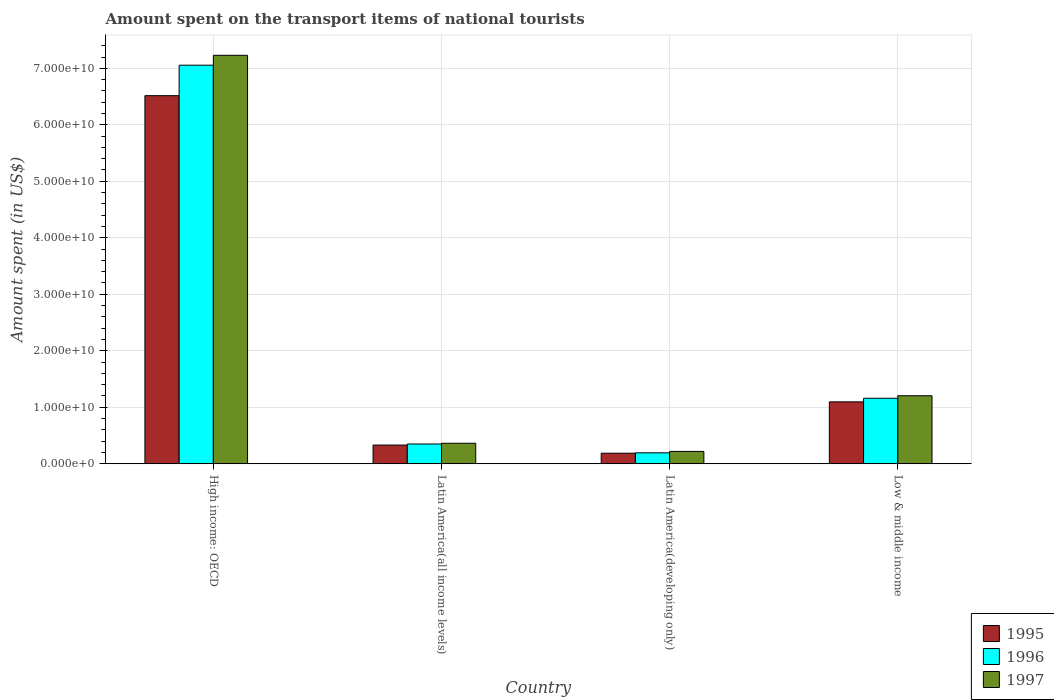How many different coloured bars are there?
Provide a succinct answer. 3. How many groups of bars are there?
Your response must be concise. 4. Are the number of bars per tick equal to the number of legend labels?
Your answer should be compact. Yes. Are the number of bars on each tick of the X-axis equal?
Provide a short and direct response. Yes. How many bars are there on the 3rd tick from the left?
Give a very brief answer. 3. How many bars are there on the 2nd tick from the right?
Make the answer very short. 3. What is the label of the 3rd group of bars from the left?
Offer a terse response. Latin America(developing only). In how many cases, is the number of bars for a given country not equal to the number of legend labels?
Offer a terse response. 0. What is the amount spent on the transport items of national tourists in 1997 in High income: OECD?
Your response must be concise. 7.23e+1. Across all countries, what is the maximum amount spent on the transport items of national tourists in 1995?
Your answer should be compact. 6.52e+1. Across all countries, what is the minimum amount spent on the transport items of national tourists in 1996?
Your answer should be compact. 1.93e+09. In which country was the amount spent on the transport items of national tourists in 1997 maximum?
Keep it short and to the point. High income: OECD. In which country was the amount spent on the transport items of national tourists in 1995 minimum?
Provide a short and direct response. Latin America(developing only). What is the total amount spent on the transport items of national tourists in 1995 in the graph?
Your answer should be very brief. 8.13e+1. What is the difference between the amount spent on the transport items of national tourists in 1995 in Latin America(all income levels) and that in Latin America(developing only)?
Your response must be concise. 1.44e+09. What is the difference between the amount spent on the transport items of national tourists in 1997 in Latin America(all income levels) and the amount spent on the transport items of national tourists in 1996 in High income: OECD?
Ensure brevity in your answer.  -6.69e+1. What is the average amount spent on the transport items of national tourists in 1996 per country?
Make the answer very short. 2.19e+1. What is the difference between the amount spent on the transport items of national tourists of/in 1996 and amount spent on the transport items of national tourists of/in 1997 in Latin America(developing only)?
Keep it short and to the point. -2.50e+08. What is the ratio of the amount spent on the transport items of national tourists in 1996 in High income: OECD to that in Latin America(developing only)?
Provide a succinct answer. 36.51. Is the amount spent on the transport items of national tourists in 1996 in High income: OECD less than that in Latin America(developing only)?
Keep it short and to the point. No. What is the difference between the highest and the second highest amount spent on the transport items of national tourists in 1997?
Give a very brief answer. 6.87e+1. What is the difference between the highest and the lowest amount spent on the transport items of national tourists in 1995?
Offer a very short reply. 6.33e+1. What does the 3rd bar from the left in High income: OECD represents?
Offer a very short reply. 1997. Is it the case that in every country, the sum of the amount spent on the transport items of national tourists in 1997 and amount spent on the transport items of national tourists in 1996 is greater than the amount spent on the transport items of national tourists in 1995?
Keep it short and to the point. Yes. Are all the bars in the graph horizontal?
Offer a very short reply. No. Are the values on the major ticks of Y-axis written in scientific E-notation?
Ensure brevity in your answer.  Yes. How are the legend labels stacked?
Keep it short and to the point. Vertical. What is the title of the graph?
Your answer should be compact. Amount spent on the transport items of national tourists. What is the label or title of the X-axis?
Your answer should be very brief. Country. What is the label or title of the Y-axis?
Offer a very short reply. Amount spent (in US$). What is the Amount spent (in US$) of 1995 in High income: OECD?
Give a very brief answer. 6.52e+1. What is the Amount spent (in US$) of 1996 in High income: OECD?
Provide a succinct answer. 7.06e+1. What is the Amount spent (in US$) in 1997 in High income: OECD?
Your response must be concise. 7.23e+1. What is the Amount spent (in US$) of 1995 in Latin America(all income levels)?
Ensure brevity in your answer.  3.31e+09. What is the Amount spent (in US$) in 1996 in Latin America(all income levels)?
Ensure brevity in your answer.  3.50e+09. What is the Amount spent (in US$) of 1997 in Latin America(all income levels)?
Your response must be concise. 3.63e+09. What is the Amount spent (in US$) in 1995 in Latin America(developing only)?
Keep it short and to the point. 1.86e+09. What is the Amount spent (in US$) of 1996 in Latin America(developing only)?
Offer a very short reply. 1.93e+09. What is the Amount spent (in US$) in 1997 in Latin America(developing only)?
Give a very brief answer. 2.18e+09. What is the Amount spent (in US$) of 1995 in Low & middle income?
Provide a short and direct response. 1.10e+1. What is the Amount spent (in US$) of 1996 in Low & middle income?
Provide a succinct answer. 1.16e+1. What is the Amount spent (in US$) in 1997 in Low & middle income?
Provide a short and direct response. 1.20e+1. Across all countries, what is the maximum Amount spent (in US$) in 1995?
Offer a very short reply. 6.52e+1. Across all countries, what is the maximum Amount spent (in US$) of 1996?
Your response must be concise. 7.06e+1. Across all countries, what is the maximum Amount spent (in US$) in 1997?
Give a very brief answer. 7.23e+1. Across all countries, what is the minimum Amount spent (in US$) of 1995?
Ensure brevity in your answer.  1.86e+09. Across all countries, what is the minimum Amount spent (in US$) in 1996?
Your answer should be compact. 1.93e+09. Across all countries, what is the minimum Amount spent (in US$) of 1997?
Keep it short and to the point. 2.18e+09. What is the total Amount spent (in US$) in 1995 in the graph?
Give a very brief answer. 8.13e+1. What is the total Amount spent (in US$) in 1996 in the graph?
Provide a short and direct response. 8.76e+1. What is the total Amount spent (in US$) in 1997 in the graph?
Your answer should be compact. 9.01e+1. What is the difference between the Amount spent (in US$) in 1995 in High income: OECD and that in Latin America(all income levels)?
Your answer should be compact. 6.19e+1. What is the difference between the Amount spent (in US$) of 1996 in High income: OECD and that in Latin America(all income levels)?
Ensure brevity in your answer.  6.71e+1. What is the difference between the Amount spent (in US$) in 1997 in High income: OECD and that in Latin America(all income levels)?
Offer a terse response. 6.87e+1. What is the difference between the Amount spent (in US$) of 1995 in High income: OECD and that in Latin America(developing only)?
Ensure brevity in your answer.  6.33e+1. What is the difference between the Amount spent (in US$) of 1996 in High income: OECD and that in Latin America(developing only)?
Offer a very short reply. 6.86e+1. What is the difference between the Amount spent (in US$) of 1997 in High income: OECD and that in Latin America(developing only)?
Keep it short and to the point. 7.01e+1. What is the difference between the Amount spent (in US$) of 1995 in High income: OECD and that in Low & middle income?
Offer a very short reply. 5.42e+1. What is the difference between the Amount spent (in US$) in 1996 in High income: OECD and that in Low & middle income?
Provide a short and direct response. 5.90e+1. What is the difference between the Amount spent (in US$) of 1997 in High income: OECD and that in Low & middle income?
Ensure brevity in your answer.  6.03e+1. What is the difference between the Amount spent (in US$) in 1995 in Latin America(all income levels) and that in Latin America(developing only)?
Offer a terse response. 1.44e+09. What is the difference between the Amount spent (in US$) of 1996 in Latin America(all income levels) and that in Latin America(developing only)?
Make the answer very short. 1.56e+09. What is the difference between the Amount spent (in US$) of 1997 in Latin America(all income levels) and that in Latin America(developing only)?
Provide a succinct answer. 1.44e+09. What is the difference between the Amount spent (in US$) of 1995 in Latin America(all income levels) and that in Low & middle income?
Provide a succinct answer. -7.65e+09. What is the difference between the Amount spent (in US$) of 1996 in Latin America(all income levels) and that in Low & middle income?
Offer a very short reply. -8.09e+09. What is the difference between the Amount spent (in US$) in 1997 in Latin America(all income levels) and that in Low & middle income?
Your response must be concise. -8.41e+09. What is the difference between the Amount spent (in US$) in 1995 in Latin America(developing only) and that in Low & middle income?
Offer a terse response. -9.09e+09. What is the difference between the Amount spent (in US$) in 1996 in Latin America(developing only) and that in Low & middle income?
Offer a very short reply. -9.65e+09. What is the difference between the Amount spent (in US$) in 1997 in Latin America(developing only) and that in Low & middle income?
Your answer should be very brief. -9.85e+09. What is the difference between the Amount spent (in US$) in 1995 in High income: OECD and the Amount spent (in US$) in 1996 in Latin America(all income levels)?
Provide a succinct answer. 6.17e+1. What is the difference between the Amount spent (in US$) in 1995 in High income: OECD and the Amount spent (in US$) in 1997 in Latin America(all income levels)?
Your answer should be very brief. 6.15e+1. What is the difference between the Amount spent (in US$) in 1996 in High income: OECD and the Amount spent (in US$) in 1997 in Latin America(all income levels)?
Your answer should be very brief. 6.69e+1. What is the difference between the Amount spent (in US$) in 1995 in High income: OECD and the Amount spent (in US$) in 1996 in Latin America(developing only)?
Your answer should be very brief. 6.32e+1. What is the difference between the Amount spent (in US$) in 1995 in High income: OECD and the Amount spent (in US$) in 1997 in Latin America(developing only)?
Keep it short and to the point. 6.30e+1. What is the difference between the Amount spent (in US$) in 1996 in High income: OECD and the Amount spent (in US$) in 1997 in Latin America(developing only)?
Provide a short and direct response. 6.84e+1. What is the difference between the Amount spent (in US$) of 1995 in High income: OECD and the Amount spent (in US$) of 1996 in Low & middle income?
Provide a short and direct response. 5.36e+1. What is the difference between the Amount spent (in US$) in 1995 in High income: OECD and the Amount spent (in US$) in 1997 in Low & middle income?
Make the answer very short. 5.31e+1. What is the difference between the Amount spent (in US$) in 1996 in High income: OECD and the Amount spent (in US$) in 1997 in Low & middle income?
Your response must be concise. 5.85e+1. What is the difference between the Amount spent (in US$) of 1995 in Latin America(all income levels) and the Amount spent (in US$) of 1996 in Latin America(developing only)?
Give a very brief answer. 1.37e+09. What is the difference between the Amount spent (in US$) of 1995 in Latin America(all income levels) and the Amount spent (in US$) of 1997 in Latin America(developing only)?
Provide a succinct answer. 1.12e+09. What is the difference between the Amount spent (in US$) in 1996 in Latin America(all income levels) and the Amount spent (in US$) in 1997 in Latin America(developing only)?
Provide a short and direct response. 1.31e+09. What is the difference between the Amount spent (in US$) in 1995 in Latin America(all income levels) and the Amount spent (in US$) in 1996 in Low & middle income?
Give a very brief answer. -8.28e+09. What is the difference between the Amount spent (in US$) of 1995 in Latin America(all income levels) and the Amount spent (in US$) of 1997 in Low & middle income?
Keep it short and to the point. -8.73e+09. What is the difference between the Amount spent (in US$) in 1996 in Latin America(all income levels) and the Amount spent (in US$) in 1997 in Low & middle income?
Make the answer very short. -8.54e+09. What is the difference between the Amount spent (in US$) in 1995 in Latin America(developing only) and the Amount spent (in US$) in 1996 in Low & middle income?
Your answer should be very brief. -9.72e+09. What is the difference between the Amount spent (in US$) in 1995 in Latin America(developing only) and the Amount spent (in US$) in 1997 in Low & middle income?
Make the answer very short. -1.02e+1. What is the difference between the Amount spent (in US$) of 1996 in Latin America(developing only) and the Amount spent (in US$) of 1997 in Low & middle income?
Your response must be concise. -1.01e+1. What is the average Amount spent (in US$) in 1995 per country?
Offer a very short reply. 2.03e+1. What is the average Amount spent (in US$) in 1996 per country?
Provide a succinct answer. 2.19e+1. What is the average Amount spent (in US$) of 1997 per country?
Provide a short and direct response. 2.25e+1. What is the difference between the Amount spent (in US$) in 1995 and Amount spent (in US$) in 1996 in High income: OECD?
Ensure brevity in your answer.  -5.40e+09. What is the difference between the Amount spent (in US$) of 1995 and Amount spent (in US$) of 1997 in High income: OECD?
Make the answer very short. -7.15e+09. What is the difference between the Amount spent (in US$) of 1996 and Amount spent (in US$) of 1997 in High income: OECD?
Make the answer very short. -1.75e+09. What is the difference between the Amount spent (in US$) in 1995 and Amount spent (in US$) in 1996 in Latin America(all income levels)?
Offer a terse response. -1.89e+08. What is the difference between the Amount spent (in US$) of 1995 and Amount spent (in US$) of 1997 in Latin America(all income levels)?
Provide a short and direct response. -3.20e+08. What is the difference between the Amount spent (in US$) in 1996 and Amount spent (in US$) in 1997 in Latin America(all income levels)?
Offer a very short reply. -1.31e+08. What is the difference between the Amount spent (in US$) in 1995 and Amount spent (in US$) in 1996 in Latin America(developing only)?
Offer a very short reply. -6.84e+07. What is the difference between the Amount spent (in US$) of 1995 and Amount spent (in US$) of 1997 in Latin America(developing only)?
Your answer should be compact. -3.19e+08. What is the difference between the Amount spent (in US$) in 1996 and Amount spent (in US$) in 1997 in Latin America(developing only)?
Your response must be concise. -2.50e+08. What is the difference between the Amount spent (in US$) in 1995 and Amount spent (in US$) in 1996 in Low & middle income?
Your response must be concise. -6.33e+08. What is the difference between the Amount spent (in US$) of 1995 and Amount spent (in US$) of 1997 in Low & middle income?
Ensure brevity in your answer.  -1.08e+09. What is the difference between the Amount spent (in US$) of 1996 and Amount spent (in US$) of 1997 in Low & middle income?
Provide a short and direct response. -4.49e+08. What is the ratio of the Amount spent (in US$) of 1995 in High income: OECD to that in Latin America(all income levels)?
Provide a succinct answer. 19.71. What is the ratio of the Amount spent (in US$) of 1996 in High income: OECD to that in Latin America(all income levels)?
Your answer should be very brief. 20.19. What is the ratio of the Amount spent (in US$) in 1997 in High income: OECD to that in Latin America(all income levels)?
Your answer should be very brief. 19.94. What is the ratio of the Amount spent (in US$) in 1995 in High income: OECD to that in Latin America(developing only)?
Your response must be concise. 34.95. What is the ratio of the Amount spent (in US$) of 1996 in High income: OECD to that in Latin America(developing only)?
Offer a very short reply. 36.51. What is the ratio of the Amount spent (in US$) in 1997 in High income: OECD to that in Latin America(developing only)?
Offer a very short reply. 33.12. What is the ratio of the Amount spent (in US$) in 1995 in High income: OECD to that in Low & middle income?
Ensure brevity in your answer.  5.95. What is the ratio of the Amount spent (in US$) in 1996 in High income: OECD to that in Low & middle income?
Give a very brief answer. 6.09. What is the ratio of the Amount spent (in US$) of 1997 in High income: OECD to that in Low & middle income?
Keep it short and to the point. 6.01. What is the ratio of the Amount spent (in US$) of 1995 in Latin America(all income levels) to that in Latin America(developing only)?
Give a very brief answer. 1.77. What is the ratio of the Amount spent (in US$) in 1996 in Latin America(all income levels) to that in Latin America(developing only)?
Offer a very short reply. 1.81. What is the ratio of the Amount spent (in US$) of 1997 in Latin America(all income levels) to that in Latin America(developing only)?
Your answer should be compact. 1.66. What is the ratio of the Amount spent (in US$) of 1995 in Latin America(all income levels) to that in Low & middle income?
Offer a very short reply. 0.3. What is the ratio of the Amount spent (in US$) of 1996 in Latin America(all income levels) to that in Low & middle income?
Provide a succinct answer. 0.3. What is the ratio of the Amount spent (in US$) in 1997 in Latin America(all income levels) to that in Low & middle income?
Give a very brief answer. 0.3. What is the ratio of the Amount spent (in US$) of 1995 in Latin America(developing only) to that in Low & middle income?
Offer a very short reply. 0.17. What is the ratio of the Amount spent (in US$) in 1996 in Latin America(developing only) to that in Low & middle income?
Give a very brief answer. 0.17. What is the ratio of the Amount spent (in US$) of 1997 in Latin America(developing only) to that in Low & middle income?
Your response must be concise. 0.18. What is the difference between the highest and the second highest Amount spent (in US$) of 1995?
Your response must be concise. 5.42e+1. What is the difference between the highest and the second highest Amount spent (in US$) of 1996?
Your response must be concise. 5.90e+1. What is the difference between the highest and the second highest Amount spent (in US$) of 1997?
Offer a very short reply. 6.03e+1. What is the difference between the highest and the lowest Amount spent (in US$) in 1995?
Provide a succinct answer. 6.33e+1. What is the difference between the highest and the lowest Amount spent (in US$) in 1996?
Your answer should be very brief. 6.86e+1. What is the difference between the highest and the lowest Amount spent (in US$) in 1997?
Offer a terse response. 7.01e+1. 